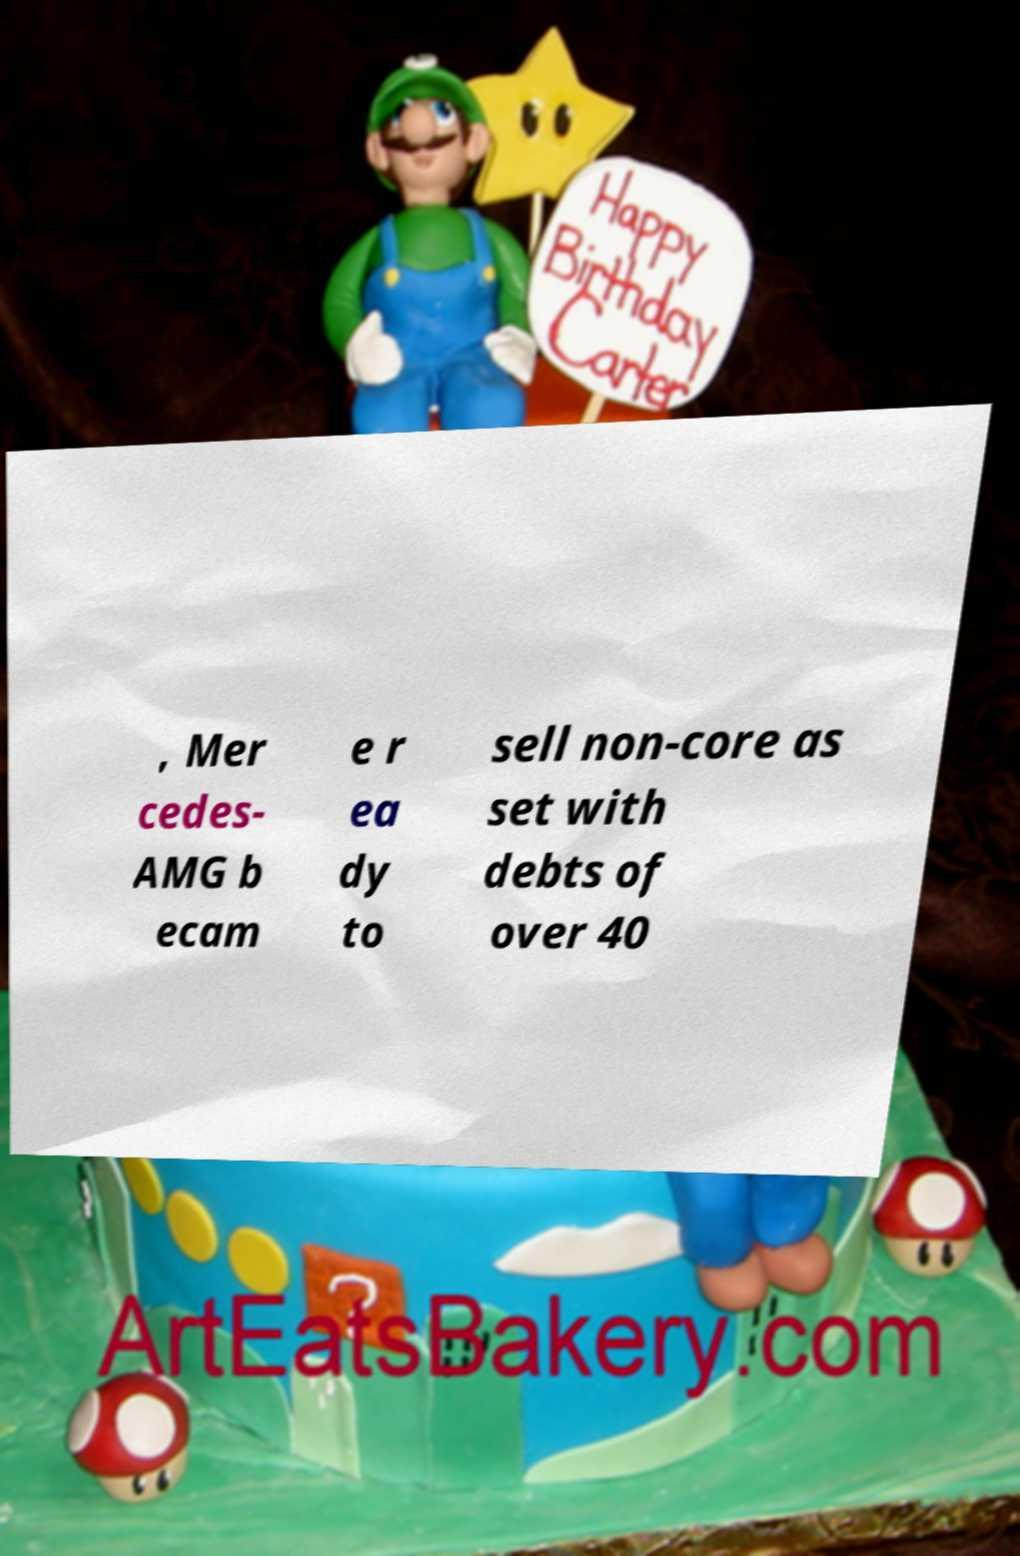Can you accurately transcribe the text from the provided image for me? , Mer cedes- AMG b ecam e r ea dy to sell non-core as set with debts of over 40 